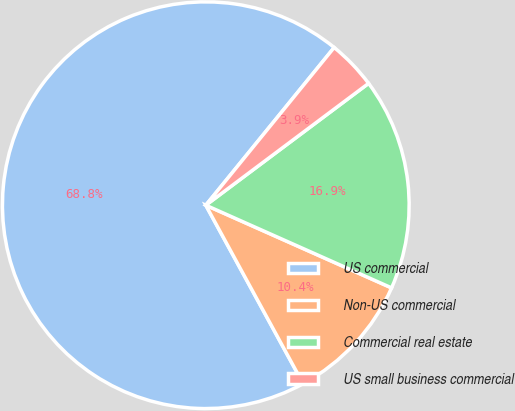<chart> <loc_0><loc_0><loc_500><loc_500><pie_chart><fcel>US commercial<fcel>Non-US commercial<fcel>Commercial real estate<fcel>US small business commercial<nl><fcel>68.82%<fcel>10.39%<fcel>16.89%<fcel>3.9%<nl></chart> 